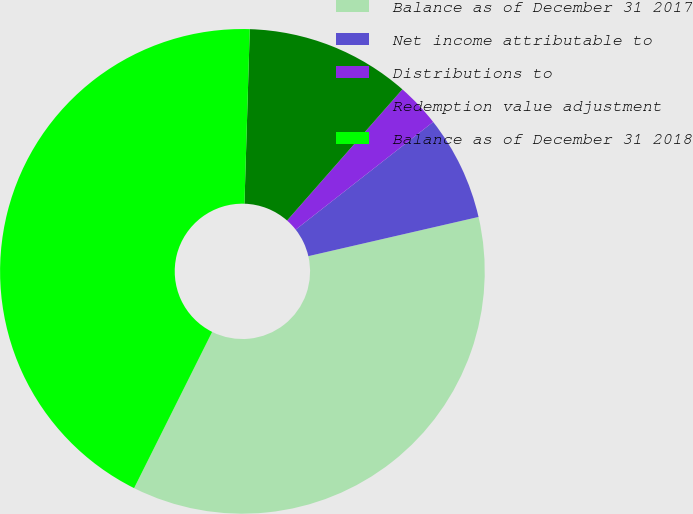<chart> <loc_0><loc_0><loc_500><loc_500><pie_chart><fcel>Balance as of December 31 2017<fcel>Net income attributable to<fcel>Distributions to<fcel>Redemption value adjustment<fcel>Balance as of December 31 2018<nl><fcel>35.98%<fcel>6.97%<fcel>2.95%<fcel>10.99%<fcel>43.11%<nl></chart> 